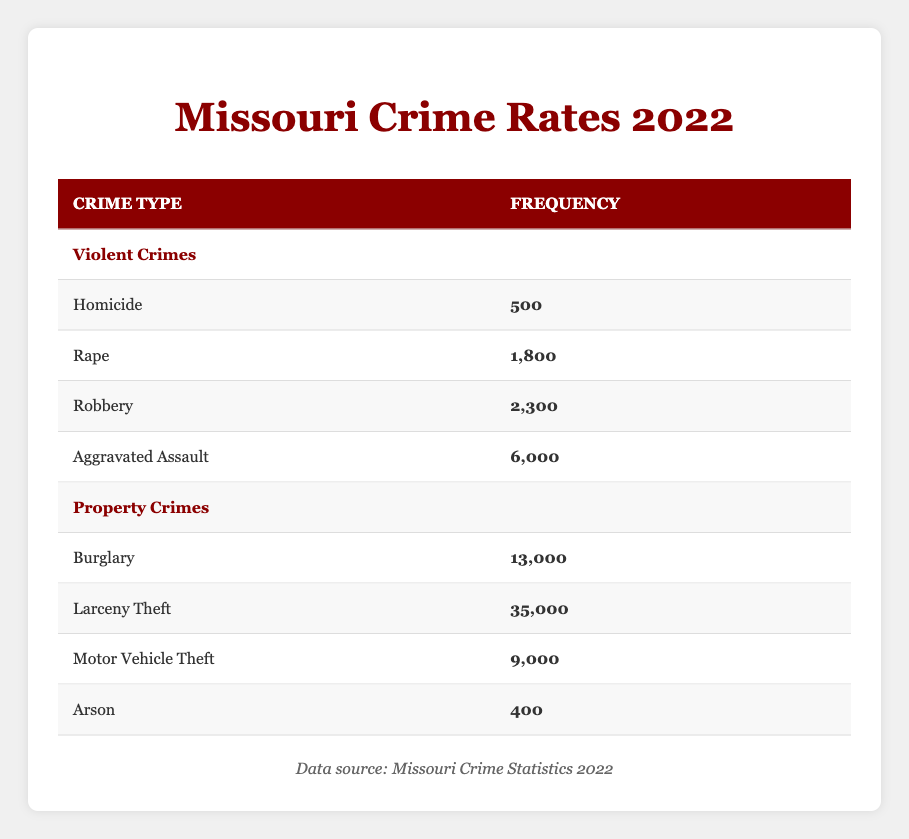What is the frequency of homicide crimes in Missouri in 2022? The table clearly shows that the frequency of homicide crimes is listed as 500.
Answer: 500 What type of crime has the highest frequency in the table? By comparing all provided frequencies, larceny theft has the highest count at 35,000, surpassing all other crime types.
Answer: Larceny theft How many total violent crimes were reported in Missouri in 2022? To find the total for violent crimes, we add the frequencies: 500 (homicide) + 1,800 (rape) + 2,300 (robbery) + 6,000 (aggravated assault) = 10,600.
Answer: 10,600 Is the frequency of arson higher than that of robbery? The frequency for robbery is 2,300, while arson's frequency is 400. Since 400 is less than 2,300, the statement is false.
Answer: No What percentage of total property crimes does burglary represent? First, we calculate the total property crimes: 13,000 (burglary) + 35,000 (larceny theft) + 9,000 (motor vehicle theft) + 400 (arson) = 57,400. The percentage for burglary is (13,000 / 57,400) * 100 = approximately 22.66%.
Answer: 22.66% Which crime type has a frequency that is the difference of aggravated assault and motor vehicle theft frequencies? Aggravated assault frequency is 6,000, and motor vehicle theft is 9,000. The difference is 6,000 - 9,000 = -3,000. Since no types have a negative frequency, none are listed.
Answer: None What is the total number of violent and property crimes combined? To find the total, we will add the total violent crimes (10,600) to the total property crimes (57,400 = 13,000 + 35,000 + 9,000 + 400). The sum is 10,600 + 57,400 = 68,000.
Answer: 68,000 Is the total frequency of property crimes greater than twice the frequency of aggravated assault? Twice the frequency of aggravated assault is 6,000 * 2 = 12,000. The total property crimes are 57,400, which is much greater than 12,000. Therefore, the statement is true.
Answer: Yes Which type of crime has the lowest frequency, and what is that frequency? The lowest frequency in the list belongs to arson, with a frequency of 400, which can be seen in the property crimes section specifically listed.
Answer: Arson, 400 